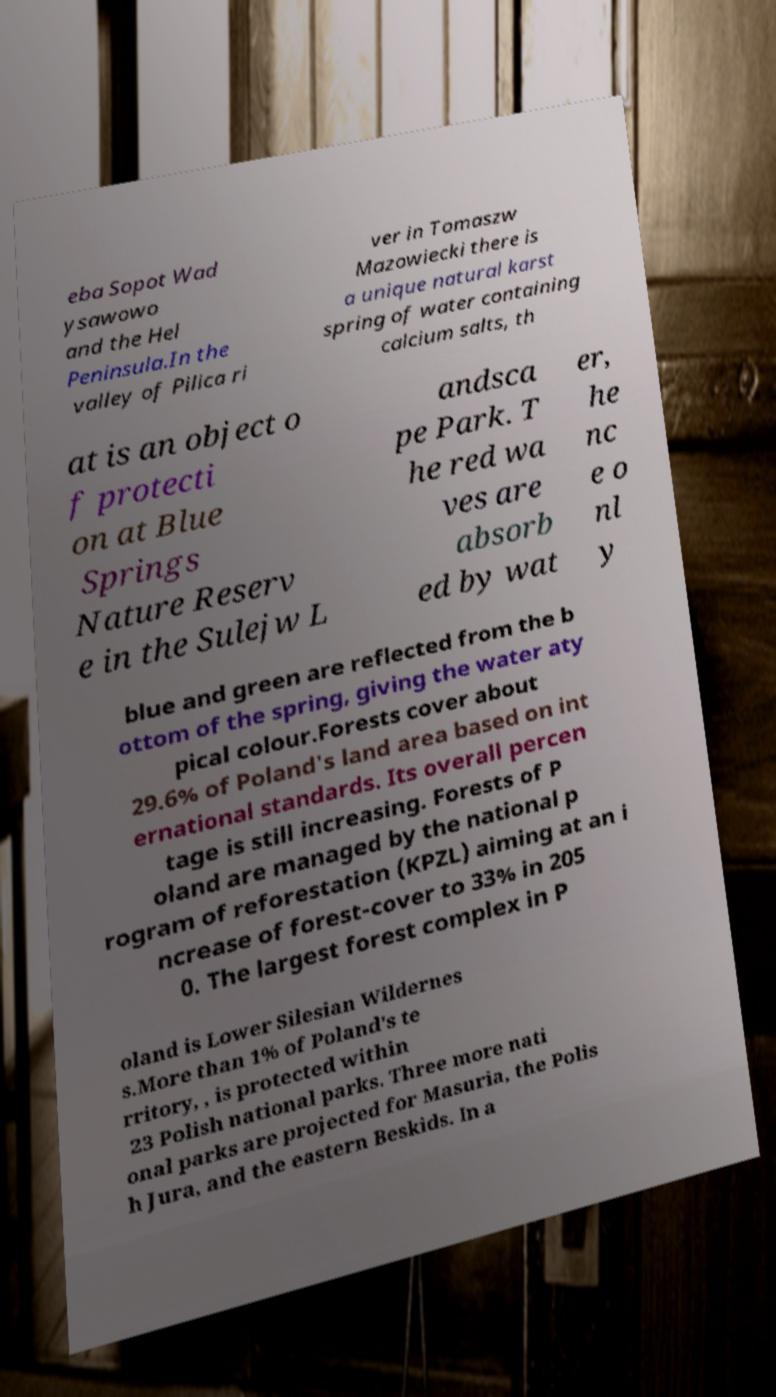Could you extract and type out the text from this image? eba Sopot Wad ysawowo and the Hel Peninsula.In the valley of Pilica ri ver in Tomaszw Mazowiecki there is a unique natural karst spring of water containing calcium salts, th at is an object o f protecti on at Blue Springs Nature Reserv e in the Sulejw L andsca pe Park. T he red wa ves are absorb ed by wat er, he nc e o nl y blue and green are reflected from the b ottom of the spring, giving the water aty pical colour.Forests cover about 29.6% of Poland's land area based on int ernational standards. Its overall percen tage is still increasing. Forests of P oland are managed by the national p rogram of reforestation (KPZL) aiming at an i ncrease of forest-cover to 33% in 205 0. The largest forest complex in P oland is Lower Silesian Wildernes s.More than 1% of Poland's te rritory, , is protected within 23 Polish national parks. Three more nati onal parks are projected for Masuria, the Polis h Jura, and the eastern Beskids. In a 